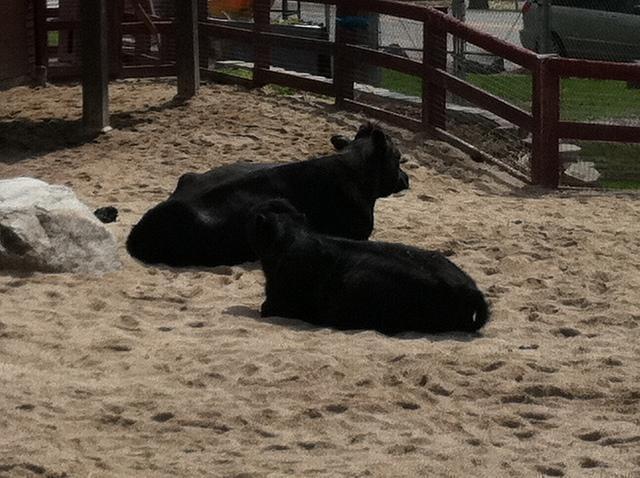What are the cows inside of?
Indicate the correct response and explain using: 'Answer: answer
Rationale: rationale.'
Options: Cardboard boxes, fence, cages, cars. Answer: fence.
Rationale: The cows are inside an enclosure that is open on top. 